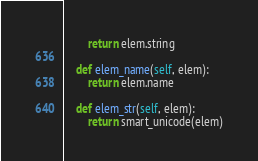Convert code to text. <code><loc_0><loc_0><loc_500><loc_500><_Python_>        return elem.string

    def elem_name(self, elem):
        return elem.name

    def elem_str(self, elem):
        return smart_unicode(elem)
</code> 